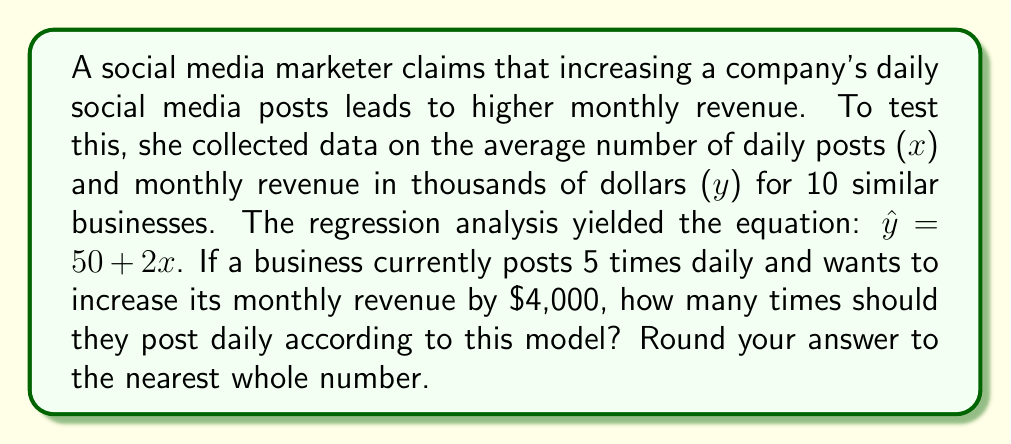What is the answer to this math problem? Let's approach this step-by-step:

1) The regression equation is $\hat{y} = 50 + 2x$, where:
   $\hat{y}$ is the predicted monthly revenue in thousands of dollars
   $x$ is the number of daily posts

2) Currently, the business posts 5 times daily. Let's calculate their current predicted revenue:
   $\hat{y} = 50 + 2(5) = 50 + 10 = 60$
   So, their current predicted monthly revenue is $60,000.

3) They want to increase revenue by $4,000, which means the new target revenue is:
   $60,000 + 4,000 = 64,000$ or $64$ in our equation (remember, y is in thousands).

4) Now, we need to solve for x in the equation:
   $64 = 50 + 2x$

5) Subtract 50 from both sides:
   $14 = 2x$

6) Divide both sides by 2:
   $7 = x$

7) Therefore, to increase revenue by $4,000, the model suggests posting 7 times daily.

8) Rounding to the nearest whole number: 7

It's important to note that this is a simplified model and real-world results may vary. Correlation doesn't imply causation, and other factors may influence revenue.
Answer: 7 posts daily 